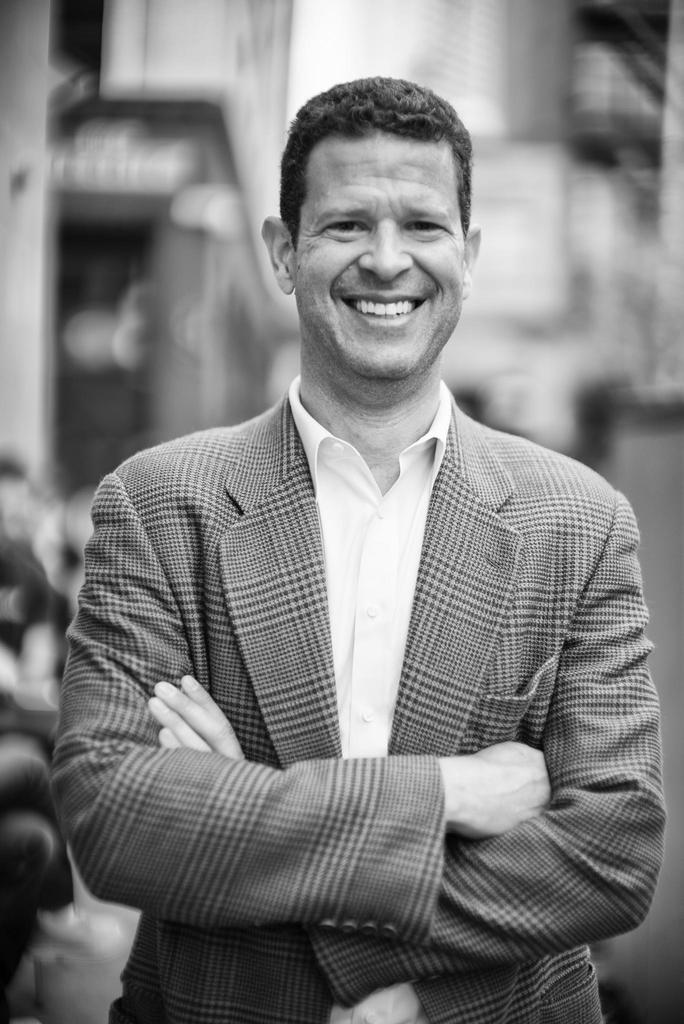What is the color scheme of the image? The image is black and white. Can you describe the person in the image? The person in the image is watching and smiling, with their hands folded. What can be observed about the background of the image? The background has a blurred view. What type of cub is visible in the image? There is no cub present in the image. What route is the person taking in the image? The image does not depict a route or any movement, so it cannot be determined. 